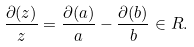Convert formula to latex. <formula><loc_0><loc_0><loc_500><loc_500>\frac { \partial ( z ) } z = \frac { \partial ( a ) } a - \frac { \partial ( b ) } b \in R .</formula> 